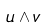Convert formula to latex. <formula><loc_0><loc_0><loc_500><loc_500>u \wedge v</formula> 